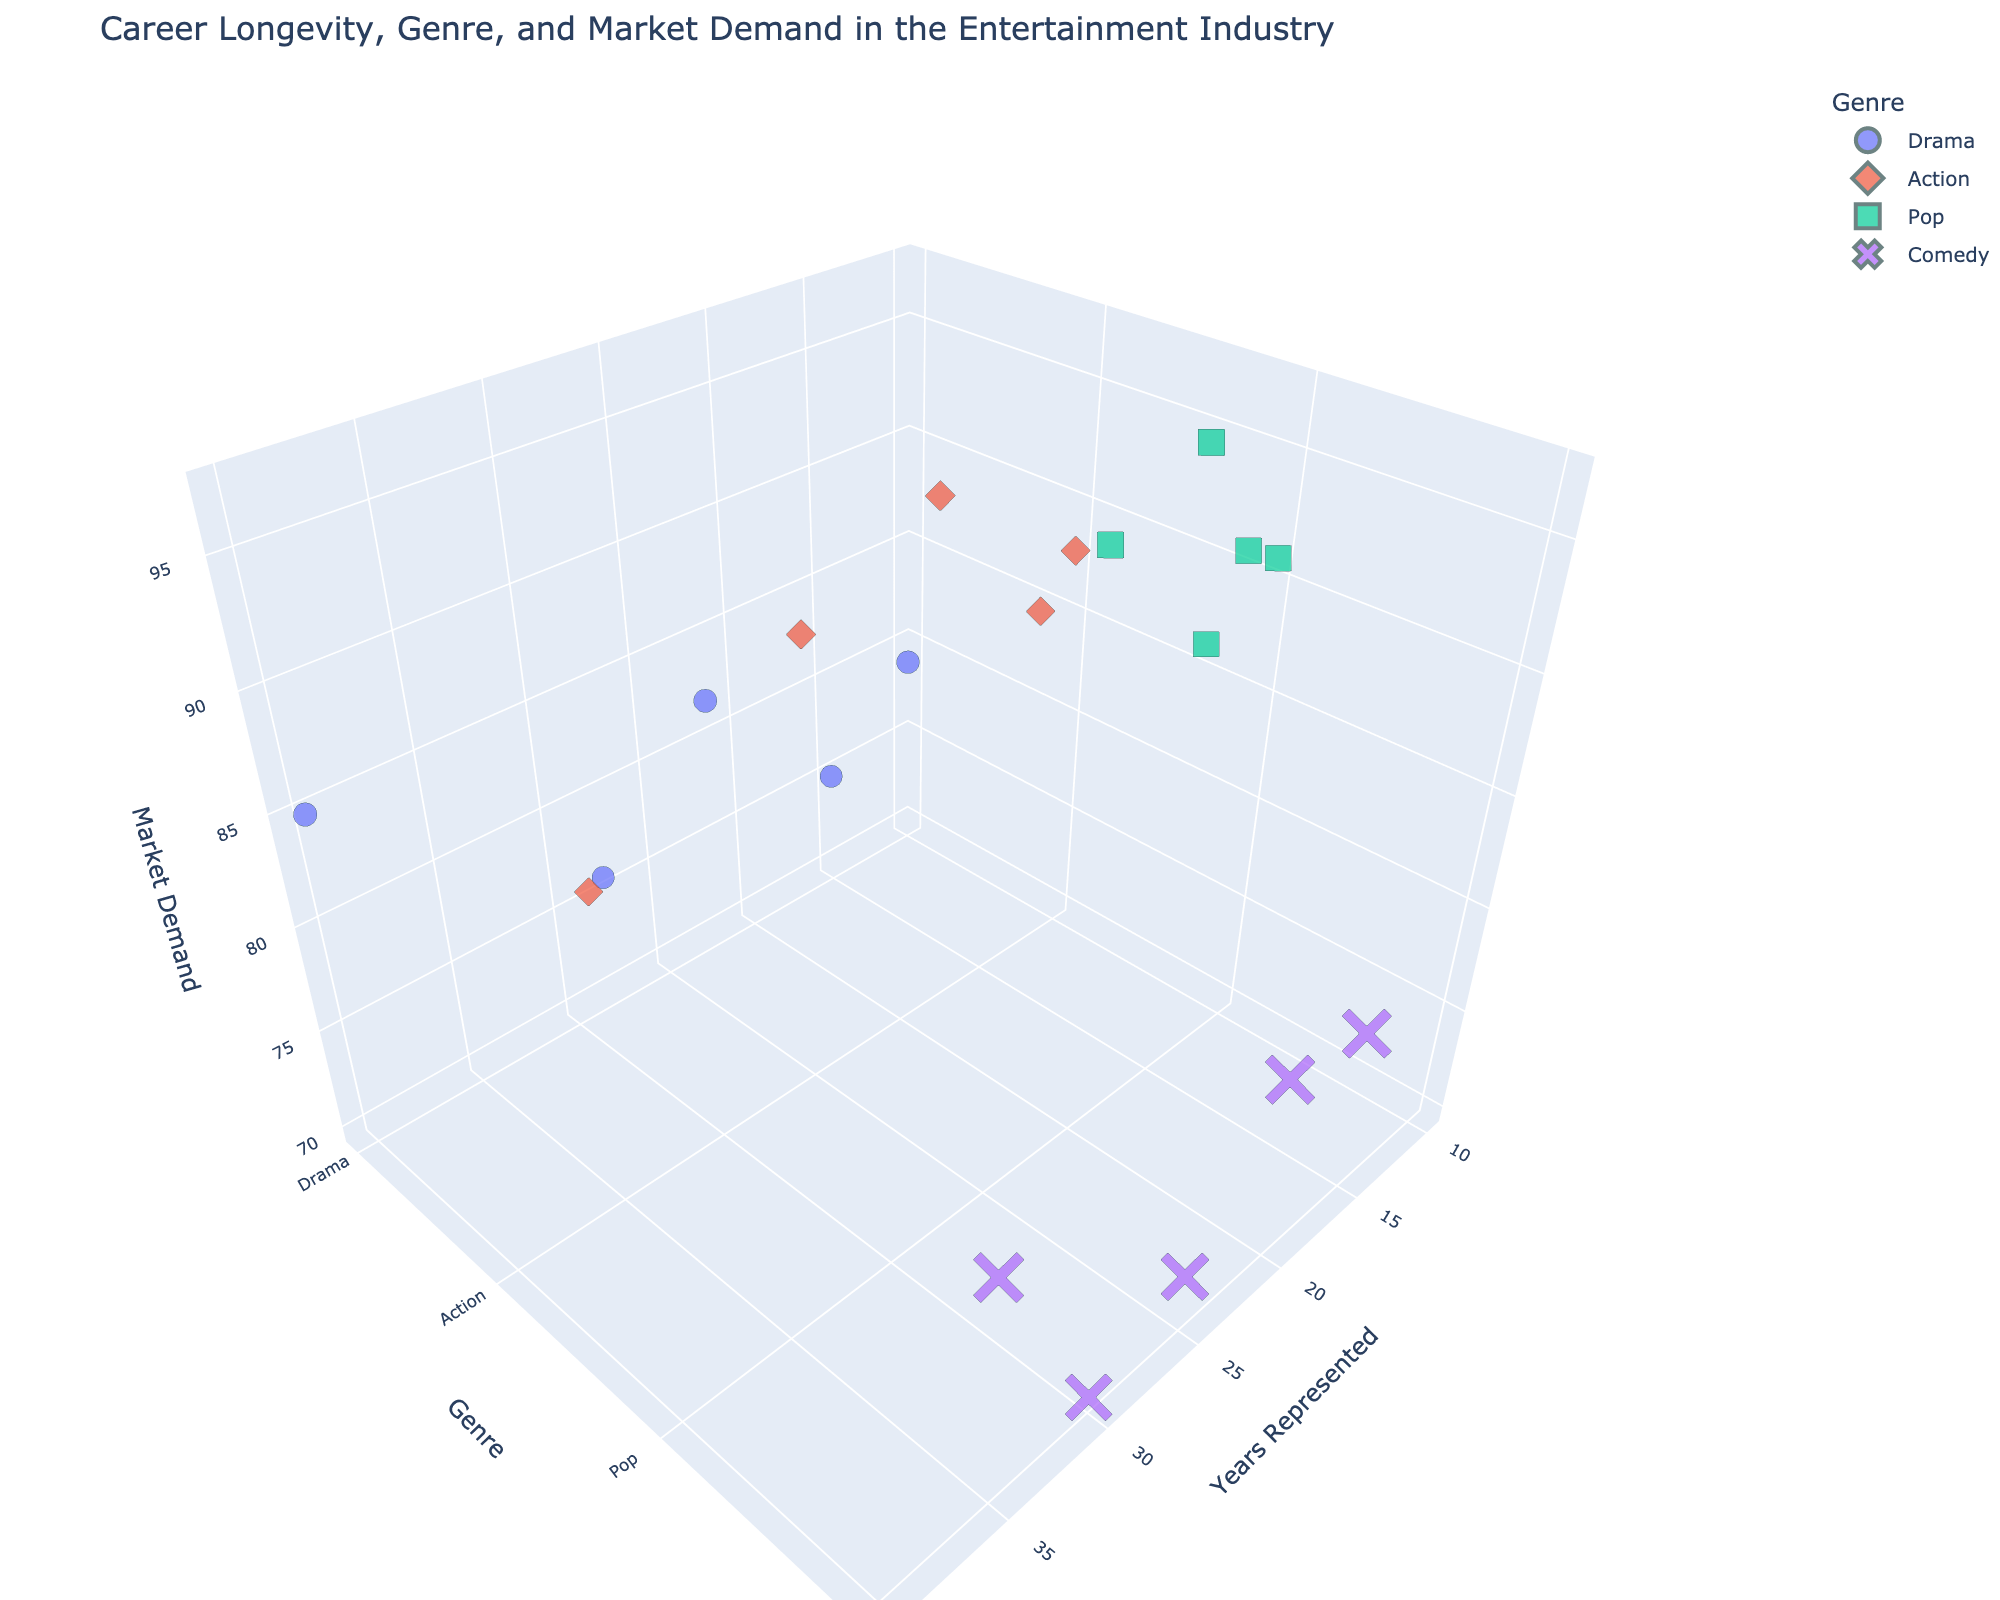How many artists are represented in the figure? To determine the number of artists shown in the figure, count the total number of data points (or markers) visible in the plot. Each data point corresponds to an artist.
Answer: 20 Which artist is represented for the longest number of years? This involves identifying the artist associated with the highest value on the 'Years Represented' axis. Look for the data point furthest along the x-axis.
Answer: Meryl Streep What is the market demand of the artist represented for the shortest number of years? Find the artist represented for the shortest duration by locating the data point closest to the origin along the 'Years Represented' axis and then check its 'Market Demand' value.
Answer: 79 (Saoirse Ronan) Which genre has the highest market demand on average? Sum up the market demands for all data points within each genre, then divide by the number of artists in that genre to compute the averages. Compare the results to identify the genre with the highest average market demand.
Answer: Pop How does the market demand for Action artists compare to Drama artists? Extract the market demand values for each artist in the 'Action' and 'Drama' genres and then compute the average for both. Compare the two average values to see which is higher.
Answer: Action > Drama Which artist has the highest market demand among those specializing in Comedy? Identify the data points labeled with the 'Comedy' genre, examine their 'Market Demand' values, and then identify the artist with the highest value.
Answer: Steve Carell Compare the career longevity between artists in Pop and Drama genres. Which genre has a higher average career longevity? For each artist in the 'Pop' and 'Drama' genres, sum their 'Years Represented' and divide by the number of artists within each genre to find the average. Compare these averages to determine which is higher.
Answer: Drama Which artist has the highest market demand with representation of more than 20 years? Look for data points where the 'Years Represented' is greater than 20, then among these points, identify the artist with the highest 'Market Demand' value.
Answer: Meryl Streep Is there any genre that consistently shows high market demand with longer career longevity? Explore data points to check if a specific genre tends to have high 'Market Demand' values consistently paired with higher 'Years Represented' values. Look for trends among genres.
Answer: Pop How does Beyoncé’s market demand compare to Ed Sheeran’s? Locate the data points corresponding to Beyoncé and Ed Sheeran, check their respective 'Market Demand' values, and compare them to determine which is higher.
Answer: Beyoncé > Ed Sheeran 